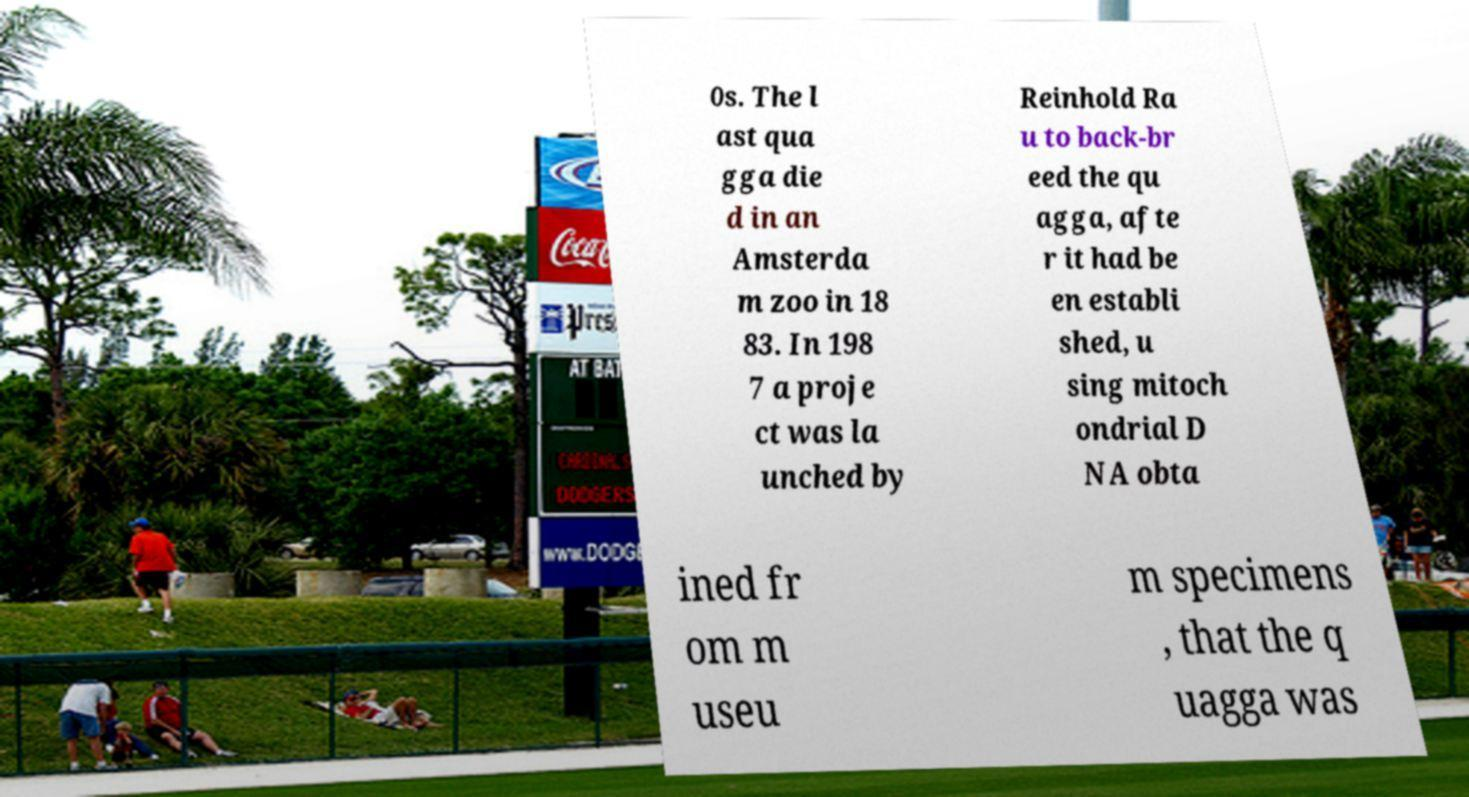I need the written content from this picture converted into text. Can you do that? 0s. The l ast qua gga die d in an Amsterda m zoo in 18 83. In 198 7 a proje ct was la unched by Reinhold Ra u to back-br eed the qu agga, afte r it had be en establi shed, u sing mitoch ondrial D NA obta ined fr om m useu m specimens , that the q uagga was 